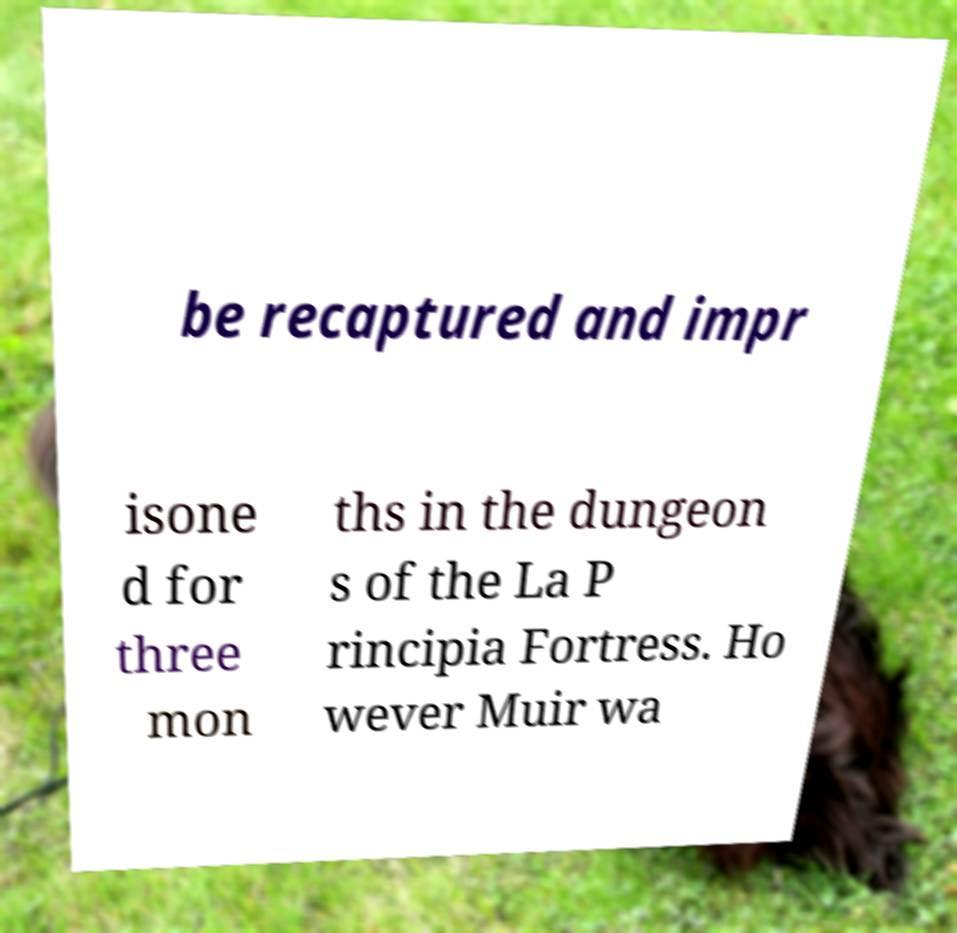Please identify and transcribe the text found in this image. be recaptured and impr isone d for three mon ths in the dungeon s of the La P rincipia Fortress. Ho wever Muir wa 